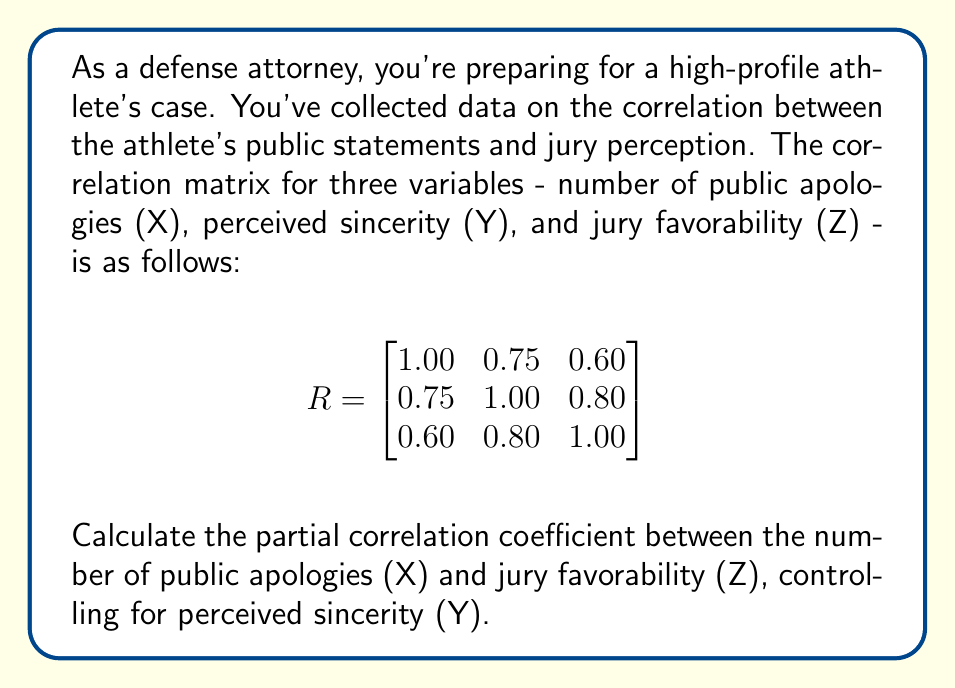What is the answer to this math problem? To calculate the partial correlation coefficient between X and Z, controlling for Y, we'll use the formula:

$$r_{XZ.Y} = \frac{r_{XZ} - r_{XY}r_{YZ}}{\sqrt{(1-r_{XY}^2)(1-r_{YZ}^2)}}$$

Where:
$r_{XZ}$ is the correlation between X and Z
$r_{XY}$ is the correlation between X and Y
$r_{YZ}$ is the correlation between Y and Z

From the given correlation matrix:
$r_{XZ} = 0.60$
$r_{XY} = 0.75$
$r_{YZ} = 0.80$

Let's substitute these values into the formula:

$$r_{XZ.Y} = \frac{0.60 - (0.75)(0.80)}{\sqrt{(1-0.75^2)(1-0.80^2)}}$$

$$= \frac{0.60 - 0.60}{\sqrt{(1-0.5625)(1-0.64)}}$$

$$= \frac{0}{\sqrt{(0.4375)(0.36)}}$$

$$= \frac{0}{\sqrt{0.1575}}$$

$$= \frac{0}{0.3969}$$

$$= 0$$
Answer: The partial correlation coefficient between the number of public apologies (X) and jury favorability (Z), controlling for perceived sincerity (Y), is 0. 